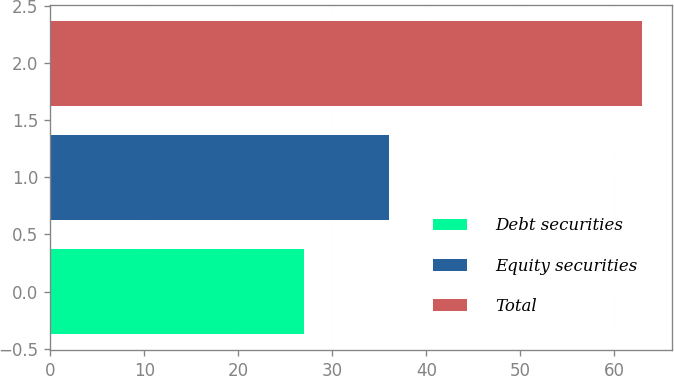Convert chart to OTSL. <chart><loc_0><loc_0><loc_500><loc_500><bar_chart><fcel>Debt securities<fcel>Equity securities<fcel>Total<nl><fcel>27<fcel>36<fcel>63<nl></chart> 